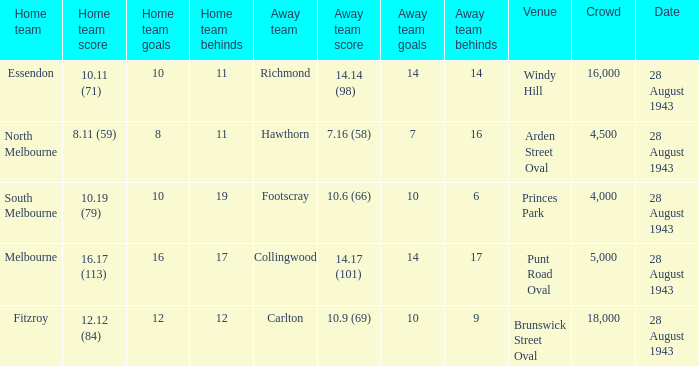Where was the game played with an away team score of 14.17 (101)? Punt Road Oval. 